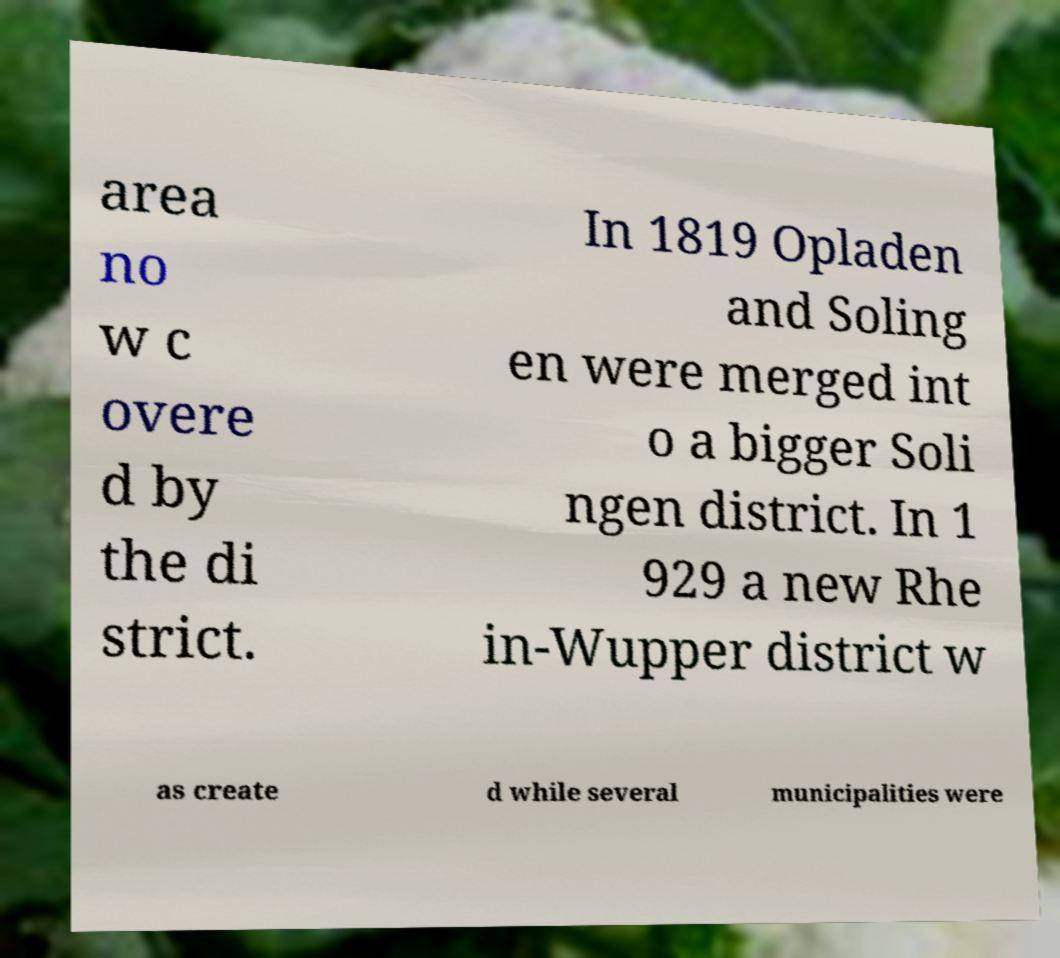Can you accurately transcribe the text from the provided image for me? area no w c overe d by the di strict. In 1819 Opladen and Soling en were merged int o a bigger Soli ngen district. In 1 929 a new Rhe in-Wupper district w as create d while several municipalities were 